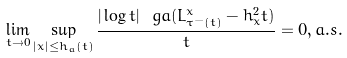<formula> <loc_0><loc_0><loc_500><loc_500>\lim _ { t \to 0 } \sup _ { | x | \leq h _ { a } ( t ) } \frac { | \log t | ^ { \ } g a ( L ^ { x } _ { \tau ^ { - } ( t ) } - h _ { x } ^ { 2 } t ) } { t } = 0 , a . s .</formula> 